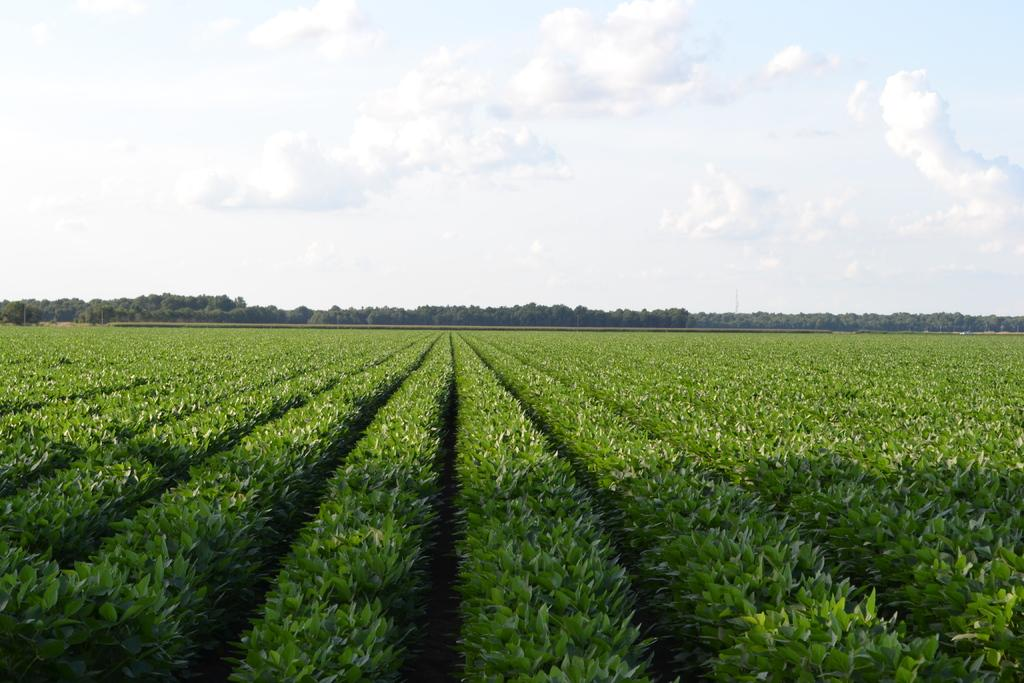What type of landscape is depicted in the image? The image features farmlands. What can be seen in the background of the image? There are trees and the sky visible in the background of the image. How would you describe the weather in the image? The sky appears to be sunny, suggesting a clear and bright day. How many apples are hanging from the trees in the image? There are no apples visible in the image; only trees are present in the background. Is there a cap visible on anyone's head in the image? There is no person present in the image, so it is impossible to determine if anyone is wearing a cap. 